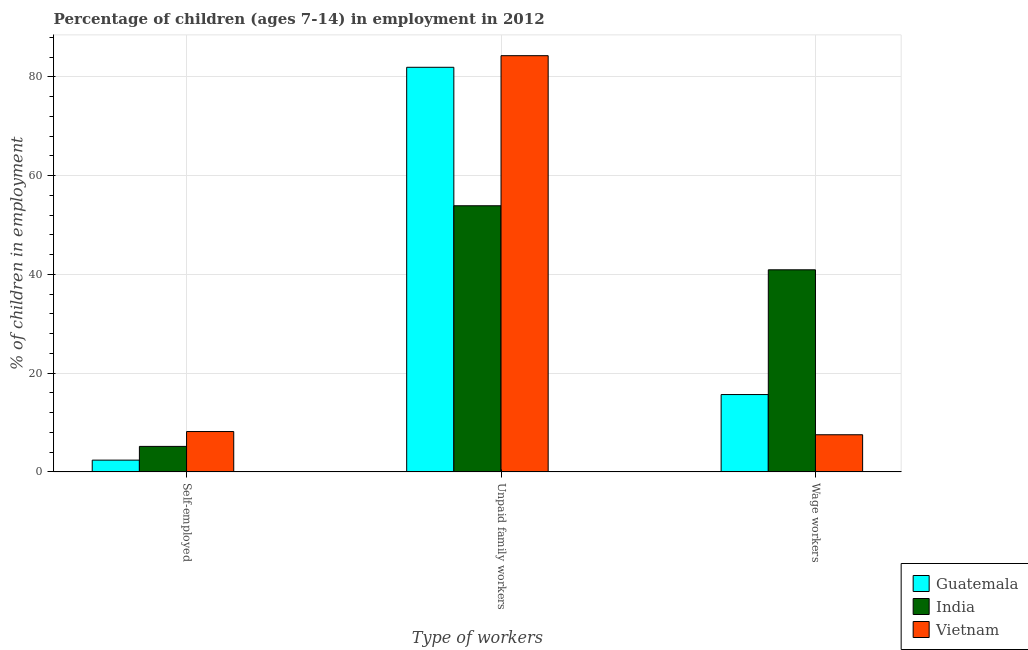How many different coloured bars are there?
Make the answer very short. 3. How many groups of bars are there?
Give a very brief answer. 3. Are the number of bars per tick equal to the number of legend labels?
Your answer should be compact. Yes. Are the number of bars on each tick of the X-axis equal?
Your response must be concise. Yes. How many bars are there on the 2nd tick from the left?
Your answer should be compact. 3. What is the label of the 2nd group of bars from the left?
Keep it short and to the point. Unpaid family workers. What is the percentage of children employed as wage workers in India?
Your response must be concise. 40.93. Across all countries, what is the maximum percentage of children employed as wage workers?
Make the answer very short. 40.93. Across all countries, what is the minimum percentage of children employed as wage workers?
Give a very brief answer. 7.53. In which country was the percentage of self employed children maximum?
Provide a short and direct response. Vietnam. In which country was the percentage of self employed children minimum?
Ensure brevity in your answer.  Guatemala. What is the total percentage of self employed children in the graph?
Your answer should be very brief. 15.74. What is the difference between the percentage of children employed as wage workers in Guatemala and that in India?
Give a very brief answer. -25.26. What is the difference between the percentage of children employed as wage workers in Vietnam and the percentage of children employed as unpaid family workers in Guatemala?
Provide a short and direct response. -74.41. What is the average percentage of self employed children per country?
Your response must be concise. 5.25. What is the difference between the percentage of self employed children and percentage of children employed as wage workers in Vietnam?
Your response must be concise. 0.65. What is the ratio of the percentage of children employed as unpaid family workers in India to that in Guatemala?
Your response must be concise. 0.66. Is the percentage of self employed children in Guatemala less than that in India?
Your answer should be very brief. Yes. Is the difference between the percentage of children employed as unpaid family workers in Guatemala and Vietnam greater than the difference between the percentage of children employed as wage workers in Guatemala and Vietnam?
Your answer should be compact. No. What is the difference between the highest and the second highest percentage of self employed children?
Your answer should be compact. 3.01. What is the difference between the highest and the lowest percentage of children employed as unpaid family workers?
Your answer should be compact. 30.39. Is the sum of the percentage of children employed as unpaid family workers in Guatemala and India greater than the maximum percentage of self employed children across all countries?
Ensure brevity in your answer.  Yes. What does the 3rd bar from the left in Self-employed represents?
Provide a succinct answer. Vietnam. What does the 2nd bar from the right in Self-employed represents?
Offer a very short reply. India. What is the difference between two consecutive major ticks on the Y-axis?
Provide a succinct answer. 20. Where does the legend appear in the graph?
Make the answer very short. Bottom right. How are the legend labels stacked?
Provide a short and direct response. Vertical. What is the title of the graph?
Your response must be concise. Percentage of children (ages 7-14) in employment in 2012. Does "Poland" appear as one of the legend labels in the graph?
Offer a terse response. No. What is the label or title of the X-axis?
Keep it short and to the point. Type of workers. What is the label or title of the Y-axis?
Give a very brief answer. % of children in employment. What is the % of children in employment in Guatemala in Self-employed?
Offer a terse response. 2.39. What is the % of children in employment in India in Self-employed?
Keep it short and to the point. 5.17. What is the % of children in employment in Vietnam in Self-employed?
Your answer should be very brief. 8.18. What is the % of children in employment of Guatemala in Unpaid family workers?
Provide a succinct answer. 81.94. What is the % of children in employment of India in Unpaid family workers?
Offer a very short reply. 53.9. What is the % of children in employment in Vietnam in Unpaid family workers?
Provide a succinct answer. 84.29. What is the % of children in employment of Guatemala in Wage workers?
Keep it short and to the point. 15.67. What is the % of children in employment in India in Wage workers?
Your answer should be very brief. 40.93. What is the % of children in employment in Vietnam in Wage workers?
Make the answer very short. 7.53. Across all Type of workers, what is the maximum % of children in employment in Guatemala?
Your response must be concise. 81.94. Across all Type of workers, what is the maximum % of children in employment in India?
Provide a succinct answer. 53.9. Across all Type of workers, what is the maximum % of children in employment in Vietnam?
Your answer should be compact. 84.29. Across all Type of workers, what is the minimum % of children in employment in Guatemala?
Keep it short and to the point. 2.39. Across all Type of workers, what is the minimum % of children in employment of India?
Offer a very short reply. 5.17. Across all Type of workers, what is the minimum % of children in employment in Vietnam?
Offer a very short reply. 7.53. What is the total % of children in employment of Guatemala in the graph?
Your answer should be very brief. 100. What is the difference between the % of children in employment in Guatemala in Self-employed and that in Unpaid family workers?
Give a very brief answer. -79.55. What is the difference between the % of children in employment in India in Self-employed and that in Unpaid family workers?
Make the answer very short. -48.73. What is the difference between the % of children in employment of Vietnam in Self-employed and that in Unpaid family workers?
Provide a short and direct response. -76.11. What is the difference between the % of children in employment of Guatemala in Self-employed and that in Wage workers?
Provide a short and direct response. -13.28. What is the difference between the % of children in employment in India in Self-employed and that in Wage workers?
Your answer should be compact. -35.76. What is the difference between the % of children in employment in Vietnam in Self-employed and that in Wage workers?
Your answer should be very brief. 0.65. What is the difference between the % of children in employment in Guatemala in Unpaid family workers and that in Wage workers?
Your answer should be compact. 66.27. What is the difference between the % of children in employment of India in Unpaid family workers and that in Wage workers?
Make the answer very short. 12.97. What is the difference between the % of children in employment of Vietnam in Unpaid family workers and that in Wage workers?
Provide a short and direct response. 76.76. What is the difference between the % of children in employment of Guatemala in Self-employed and the % of children in employment of India in Unpaid family workers?
Your answer should be compact. -51.51. What is the difference between the % of children in employment in Guatemala in Self-employed and the % of children in employment in Vietnam in Unpaid family workers?
Make the answer very short. -81.9. What is the difference between the % of children in employment of India in Self-employed and the % of children in employment of Vietnam in Unpaid family workers?
Ensure brevity in your answer.  -79.12. What is the difference between the % of children in employment of Guatemala in Self-employed and the % of children in employment of India in Wage workers?
Ensure brevity in your answer.  -38.54. What is the difference between the % of children in employment of Guatemala in Self-employed and the % of children in employment of Vietnam in Wage workers?
Provide a short and direct response. -5.14. What is the difference between the % of children in employment in India in Self-employed and the % of children in employment in Vietnam in Wage workers?
Provide a short and direct response. -2.36. What is the difference between the % of children in employment of Guatemala in Unpaid family workers and the % of children in employment of India in Wage workers?
Offer a very short reply. 41.01. What is the difference between the % of children in employment of Guatemala in Unpaid family workers and the % of children in employment of Vietnam in Wage workers?
Make the answer very short. 74.41. What is the difference between the % of children in employment in India in Unpaid family workers and the % of children in employment in Vietnam in Wage workers?
Offer a very short reply. 46.37. What is the average % of children in employment of Guatemala per Type of workers?
Keep it short and to the point. 33.33. What is the average % of children in employment in India per Type of workers?
Your answer should be very brief. 33.33. What is the average % of children in employment of Vietnam per Type of workers?
Provide a short and direct response. 33.33. What is the difference between the % of children in employment in Guatemala and % of children in employment in India in Self-employed?
Keep it short and to the point. -2.78. What is the difference between the % of children in employment of Guatemala and % of children in employment of Vietnam in Self-employed?
Your response must be concise. -5.79. What is the difference between the % of children in employment in India and % of children in employment in Vietnam in Self-employed?
Ensure brevity in your answer.  -3.01. What is the difference between the % of children in employment in Guatemala and % of children in employment in India in Unpaid family workers?
Provide a short and direct response. 28.04. What is the difference between the % of children in employment of Guatemala and % of children in employment of Vietnam in Unpaid family workers?
Provide a short and direct response. -2.35. What is the difference between the % of children in employment in India and % of children in employment in Vietnam in Unpaid family workers?
Offer a very short reply. -30.39. What is the difference between the % of children in employment of Guatemala and % of children in employment of India in Wage workers?
Offer a very short reply. -25.26. What is the difference between the % of children in employment in Guatemala and % of children in employment in Vietnam in Wage workers?
Your answer should be very brief. 8.14. What is the difference between the % of children in employment in India and % of children in employment in Vietnam in Wage workers?
Your answer should be very brief. 33.4. What is the ratio of the % of children in employment of Guatemala in Self-employed to that in Unpaid family workers?
Provide a short and direct response. 0.03. What is the ratio of the % of children in employment of India in Self-employed to that in Unpaid family workers?
Your response must be concise. 0.1. What is the ratio of the % of children in employment in Vietnam in Self-employed to that in Unpaid family workers?
Provide a succinct answer. 0.1. What is the ratio of the % of children in employment in Guatemala in Self-employed to that in Wage workers?
Give a very brief answer. 0.15. What is the ratio of the % of children in employment in India in Self-employed to that in Wage workers?
Give a very brief answer. 0.13. What is the ratio of the % of children in employment of Vietnam in Self-employed to that in Wage workers?
Offer a terse response. 1.09. What is the ratio of the % of children in employment in Guatemala in Unpaid family workers to that in Wage workers?
Your answer should be compact. 5.23. What is the ratio of the % of children in employment in India in Unpaid family workers to that in Wage workers?
Your response must be concise. 1.32. What is the ratio of the % of children in employment of Vietnam in Unpaid family workers to that in Wage workers?
Offer a very short reply. 11.19. What is the difference between the highest and the second highest % of children in employment of Guatemala?
Your answer should be very brief. 66.27. What is the difference between the highest and the second highest % of children in employment in India?
Offer a terse response. 12.97. What is the difference between the highest and the second highest % of children in employment of Vietnam?
Offer a very short reply. 76.11. What is the difference between the highest and the lowest % of children in employment of Guatemala?
Keep it short and to the point. 79.55. What is the difference between the highest and the lowest % of children in employment in India?
Give a very brief answer. 48.73. What is the difference between the highest and the lowest % of children in employment of Vietnam?
Provide a short and direct response. 76.76. 